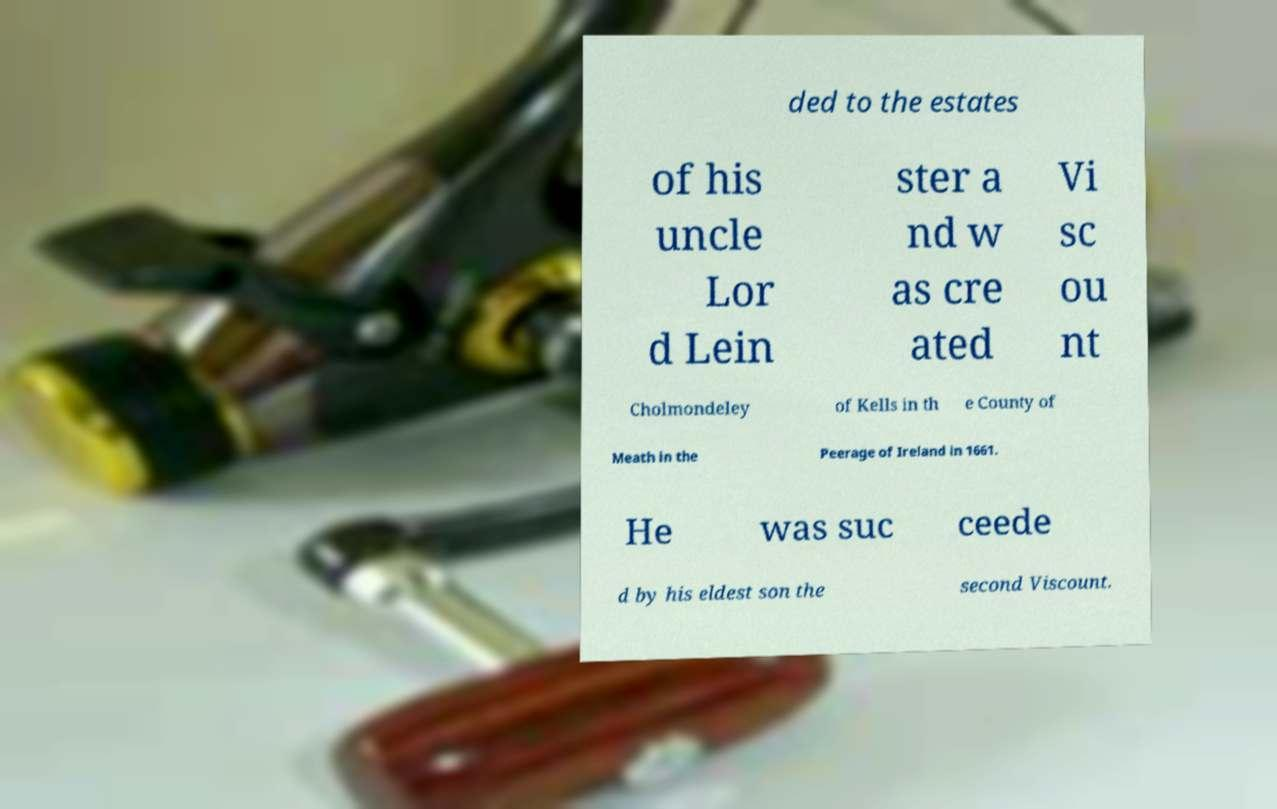I need the written content from this picture converted into text. Can you do that? ded to the estates of his uncle Lor d Lein ster a nd w as cre ated Vi sc ou nt Cholmondeley of Kells in th e County of Meath in the Peerage of Ireland in 1661. He was suc ceede d by his eldest son the second Viscount. 